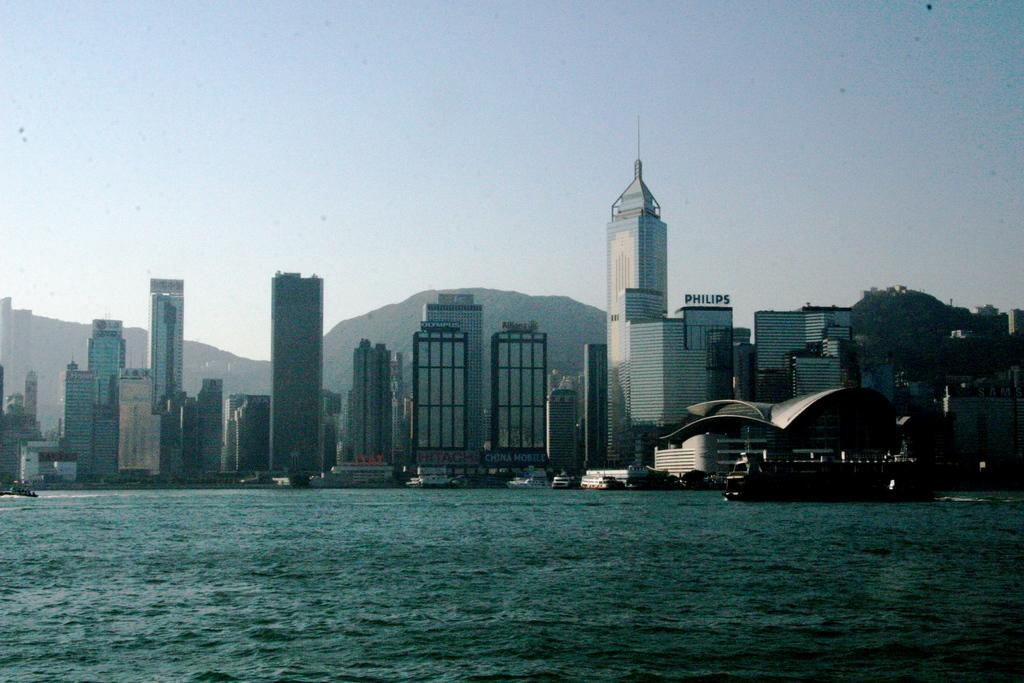What is the main subject in the image? There is a ship above the water in the image. What else can be seen in the background of the image? There are boats, buildings, hills, and the sky visible in the background of the image. What type of vegetable is being taxed in the image? There is no vegetable or taxation mentioned or depicted in the image. 